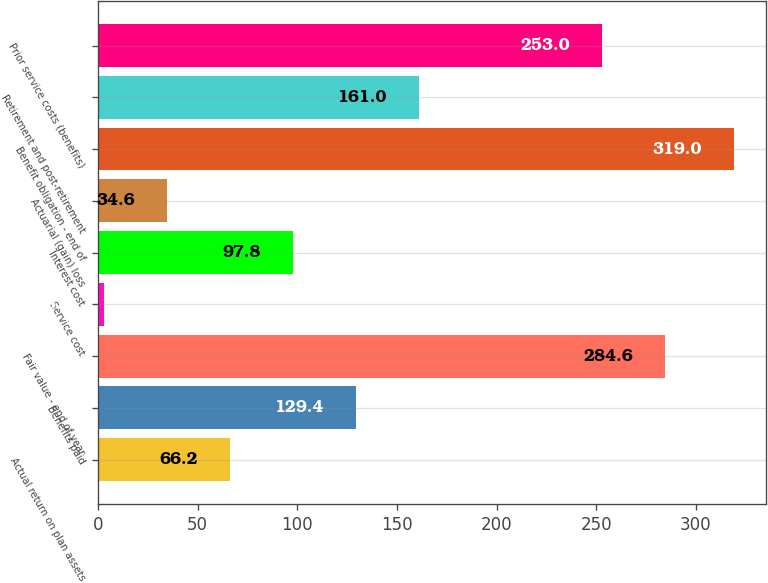<chart> <loc_0><loc_0><loc_500><loc_500><bar_chart><fcel>Actual return on plan assets<fcel>Benefits paid<fcel>Fair value - end of year<fcel>Service cost<fcel>Interest cost<fcel>Actuarial (gain) loss<fcel>Benefit obligation - end of<fcel>Retirement and post-retirement<fcel>Prior service costs (benefits)<nl><fcel>66.2<fcel>129.4<fcel>284.6<fcel>3<fcel>97.8<fcel>34.6<fcel>319<fcel>161<fcel>253<nl></chart> 